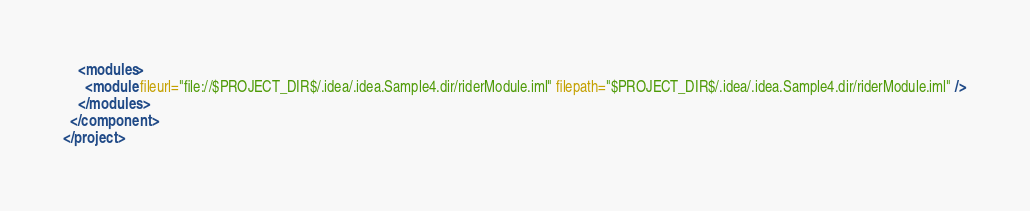Convert code to text. <code><loc_0><loc_0><loc_500><loc_500><_XML_>    <modules>
      <module fileurl="file://$PROJECT_DIR$/.idea/.idea.Sample4.dir/riderModule.iml" filepath="$PROJECT_DIR$/.idea/.idea.Sample4.dir/riderModule.iml" />
    </modules>
  </component>
</project></code> 